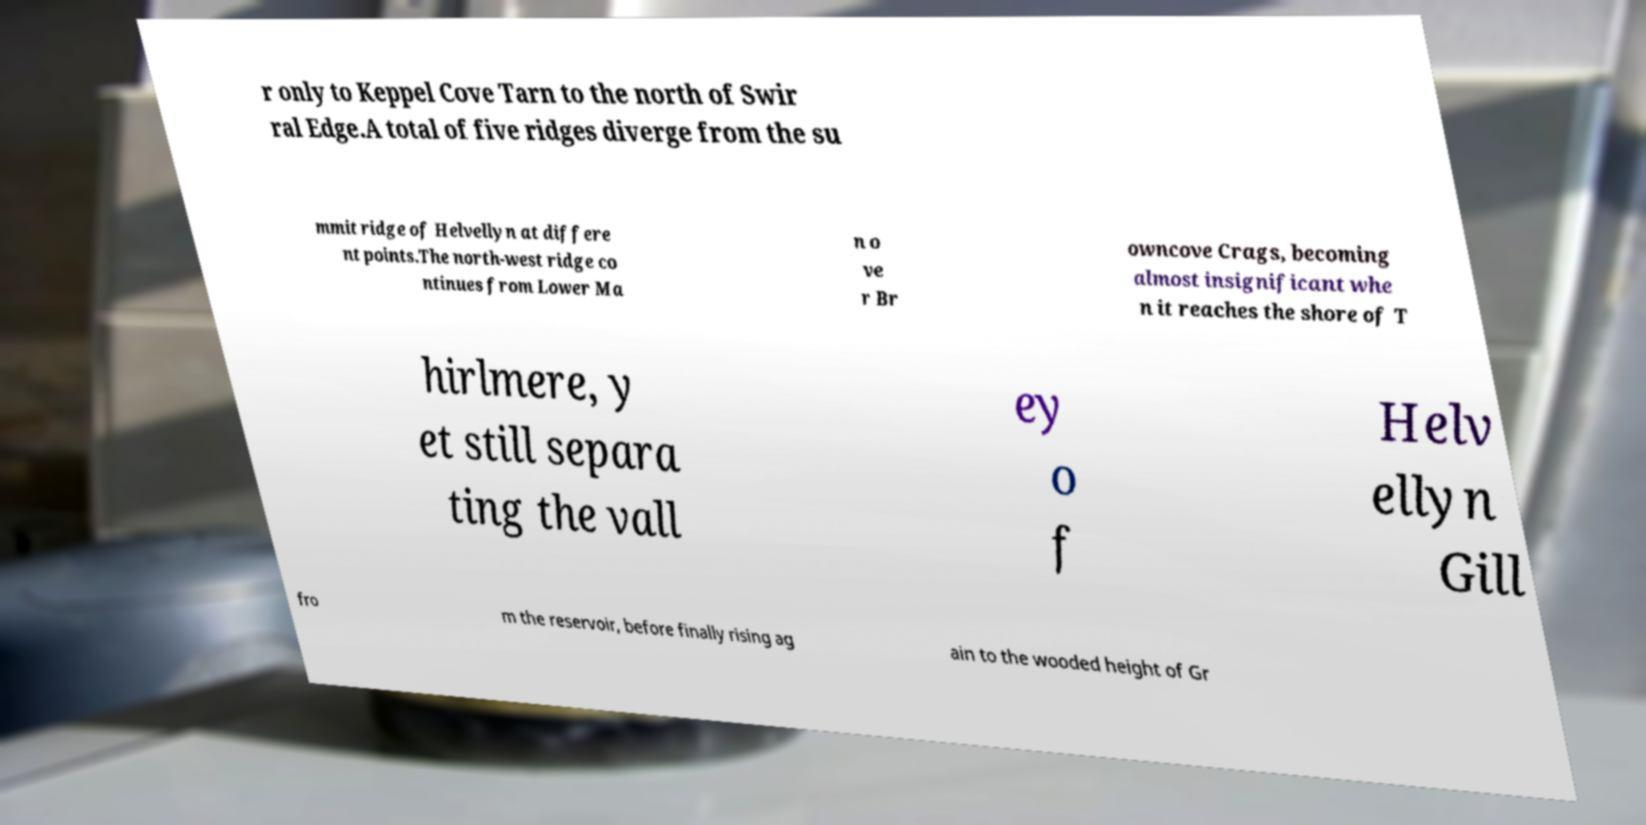Can you accurately transcribe the text from the provided image for me? r only to Keppel Cove Tarn to the north of Swir ral Edge.A total of five ridges diverge from the su mmit ridge of Helvellyn at differe nt points.The north-west ridge co ntinues from Lower Ma n o ve r Br owncove Crags, becoming almost insignificant whe n it reaches the shore of T hirlmere, y et still separa ting the vall ey o f Helv ellyn Gill fro m the reservoir, before finally rising ag ain to the wooded height of Gr 